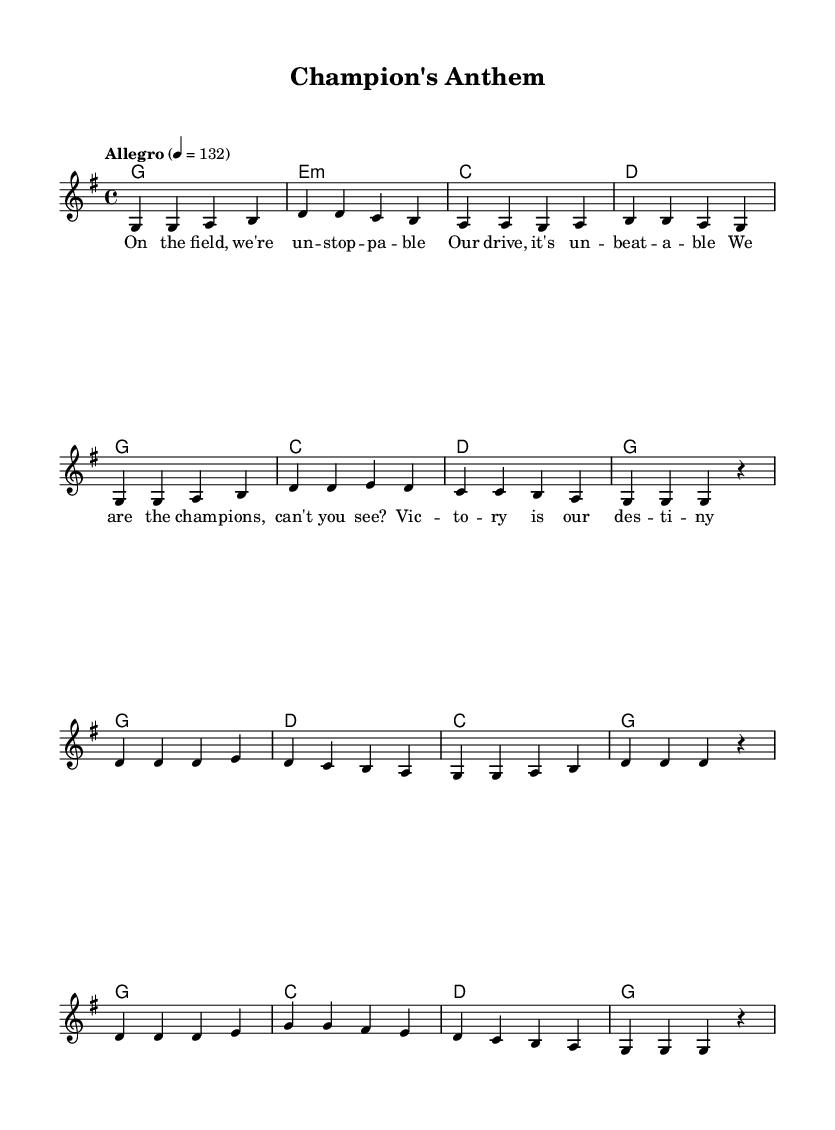What is the key signature of this music? The key signature is G major, which has one sharp (F#). This can be determined by looking at the key signature indicated at the beginning of the score, before the time signature.
Answer: G major What is the time signature of this music? The time signature is 4/4, which indicates four beats per measure. This is shown at the beginning of the score right after the key signature.
Answer: 4/4 What is the tempo marking of this piece? The tempo marking is "Allegro," which means to play fast and lively. This is indicated at the start of the score along with the beats per minute (BPM) of 132.
Answer: Allegro How many measures are in the chorus section? There are eight measures in the chorus. This can be determined by counting the measures from the start to the end of the chorus sections in the score.
Answer: Eight What is the tonic chord of the piece? The tonic chord is G major, as it is the first chord in the harmony section and provides the tonal center for the piece. This can be seen in the harmonies line, where G is the first chord listed.
Answer: G Which lyric corresponds to the first measure of the melody? The lyric corresponding to the first measure is "On the field, we're un -- stop -- pa -- ble." This can be found by aligning the lyrics with the melody in the score.
Answer: On the field, we're un -- stop -- pa -- ble What is the last lyric sung before the chorus? The last lyric sung before the chorus is "g g g r," which indicates a rest in the melody line. This can be traced from the melody section just before the chorus begins.
Answer: g g g r 